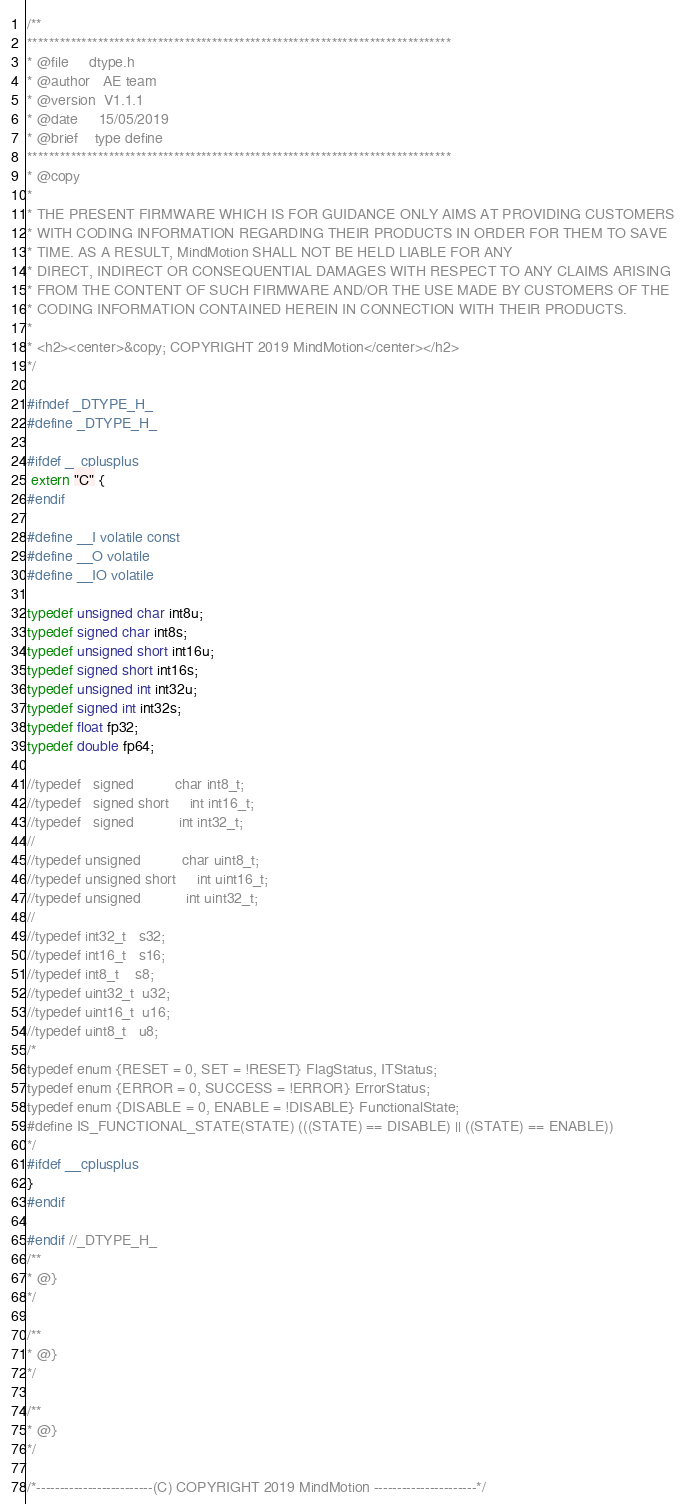<code> <loc_0><loc_0><loc_500><loc_500><_C_>/**
******************************************************************************
* @file     dtype.h
* @author   AE team
* @version  V1.1.1
* @date     15/05/2019
* @brief    type define
******************************************************************************
* @copy
*
* THE PRESENT FIRMWARE WHICH IS FOR GUIDANCE ONLY AIMS AT PROVIDING CUSTOMERS
* WITH CODING INFORMATION REGARDING THEIR PRODUCTS IN ORDER FOR THEM TO SAVE
* TIME. AS A RESULT, MindMotion SHALL NOT BE HELD LIABLE FOR ANY
* DIRECT, INDIRECT OR CONSEQUENTIAL DAMAGES WITH RESPECT TO ANY CLAIMS ARISING
* FROM THE CONTENT OF SUCH FIRMWARE AND/OR THE USE MADE BY CUSTOMERS OF THE
* CODING INFORMATION CONTAINED HEREIN IN CONNECTION WITH THEIR PRODUCTS.
*
* <h2><center>&copy; COPYRIGHT 2019 MindMotion</center></h2>
*/

#ifndef _DTYPE_H_
#define _DTYPE_H_

#ifdef __cplusplus
 extern "C" {
#endif

#define __I volatile const
#define __O volatile
#define __IO volatile

typedef unsigned char int8u;
typedef signed char int8s;
typedef unsigned short int16u;
typedef signed short int16s;
typedef unsigned int int32u;
typedef signed int int32s;
typedef float fp32;
typedef double fp64;

//typedef   signed          char int8_t;
//typedef   signed short     int int16_t;
//typedef   signed           int int32_t;
//
//typedef unsigned          char uint8_t;
//typedef unsigned short     int uint16_t;
//typedef unsigned           int uint32_t;
//
//typedef int32_t   s32;
//typedef int16_t   s16;
//typedef int8_t    s8;
//typedef uint32_t  u32;
//typedef uint16_t  u16;
//typedef uint8_t   u8;
/*
typedef enum {RESET = 0, SET = !RESET} FlagStatus, ITStatus;
typedef enum {ERROR = 0, SUCCESS = !ERROR} ErrorStatus;
typedef enum {DISABLE = 0, ENABLE = !DISABLE} FunctionalState;
#define IS_FUNCTIONAL_STATE(STATE) (((STATE) == DISABLE) || ((STATE) == ENABLE))
*/
#ifdef __cplusplus
}
#endif

#endif //_DTYPE_H_
/**
* @}
*/

/**
* @}
*/

/**
* @}
*/

/*-------------------------(C) COPYRIGHT 2019 MindMotion ----------------------*/
</code> 